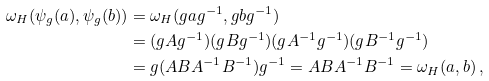<formula> <loc_0><loc_0><loc_500><loc_500>\omega _ { H } ( \psi _ { g } ( a ) , \psi _ { g } ( b ) ) & = \omega _ { H } ( g a g ^ { - 1 } , g b g ^ { - 1 } ) \\ & = ( g A g ^ { - 1 } ) ( g B g ^ { - 1 } ) ( g A ^ { - 1 } g ^ { - 1 } ) ( g B ^ { - 1 } g ^ { - 1 } ) \\ & = g ( A B A ^ { - 1 } B ^ { - 1 } ) g ^ { - 1 } = A B A ^ { - 1 } B ^ { - 1 } = \omega _ { H } ( a , b ) \, ,</formula> 